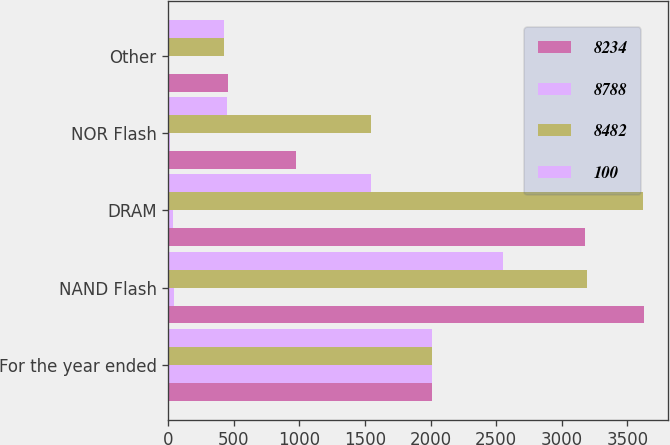<chart> <loc_0><loc_0><loc_500><loc_500><stacked_bar_chart><ecel><fcel>For the year ended<fcel>NAND Flash<fcel>DRAM<fcel>NOR Flash<fcel>Other<nl><fcel>8234<fcel>2012<fcel>3627<fcel>3178<fcel>977<fcel>452<nl><fcel>8788<fcel>2012<fcel>44<fcel>39<fcel>12<fcel>5<nl><fcel>8482<fcel>2011<fcel>3193<fcel>3620<fcel>1547<fcel>428<nl><fcel>100<fcel>2010<fcel>2555<fcel>1547<fcel>451<fcel>424<nl></chart> 